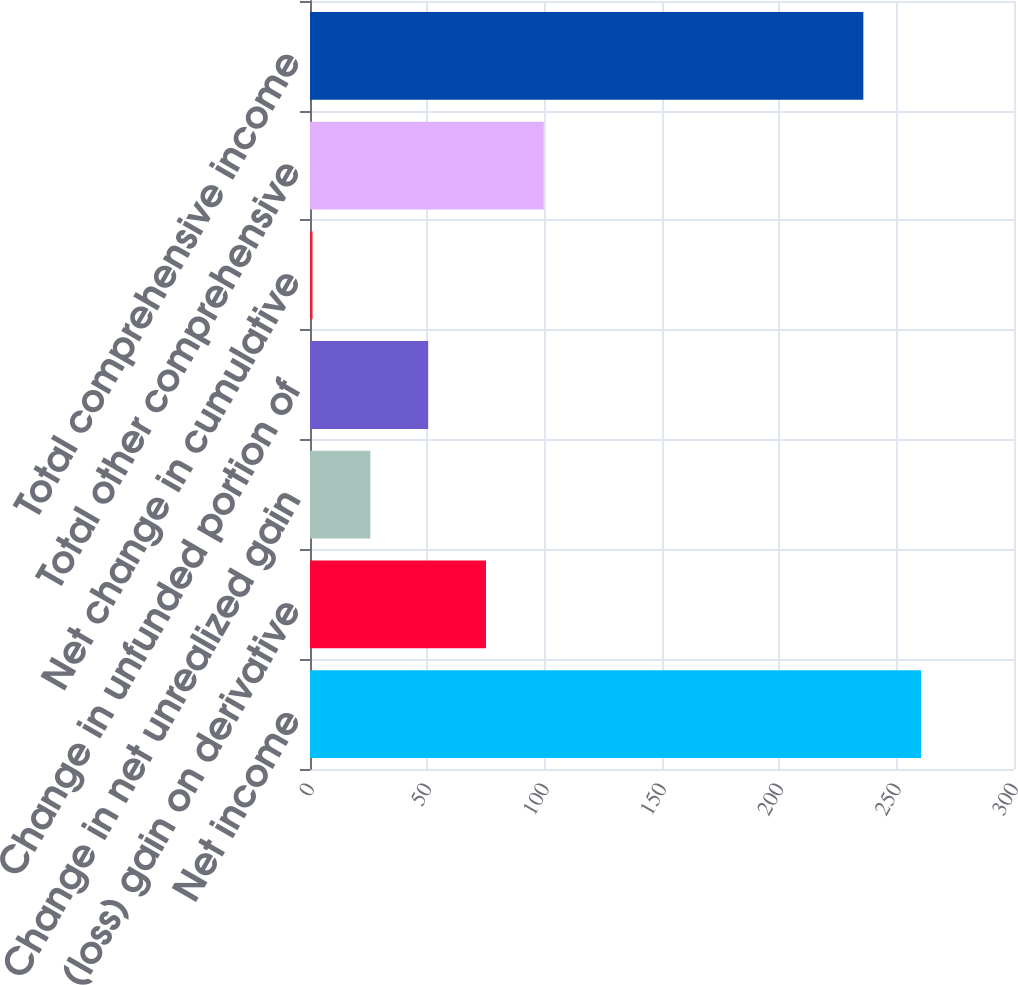Convert chart. <chart><loc_0><loc_0><loc_500><loc_500><bar_chart><fcel>Net income<fcel>Net (loss) gain on derivative<fcel>Change in net unrealized gain<fcel>Change in unfunded portion of<fcel>Net change in cumulative<fcel>Total other comprehensive<fcel>Total comprehensive income<nl><fcel>260.43<fcel>74.99<fcel>25.73<fcel>50.36<fcel>1.1<fcel>99.62<fcel>235.8<nl></chart> 